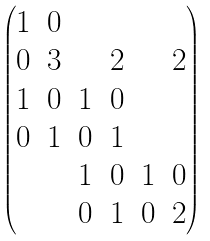Convert formula to latex. <formula><loc_0><loc_0><loc_500><loc_500>\begin{pmatrix} 1 & 0 & & & & \\ 0 & 3 & & 2 & & 2 \\ 1 & 0 & 1 & 0 & & \\ 0 & 1 & 0 & 1 & & \\ & & 1 & 0 & 1 & 0 \\ & & 0 & 1 & 0 & 2 \end{pmatrix}</formula> 